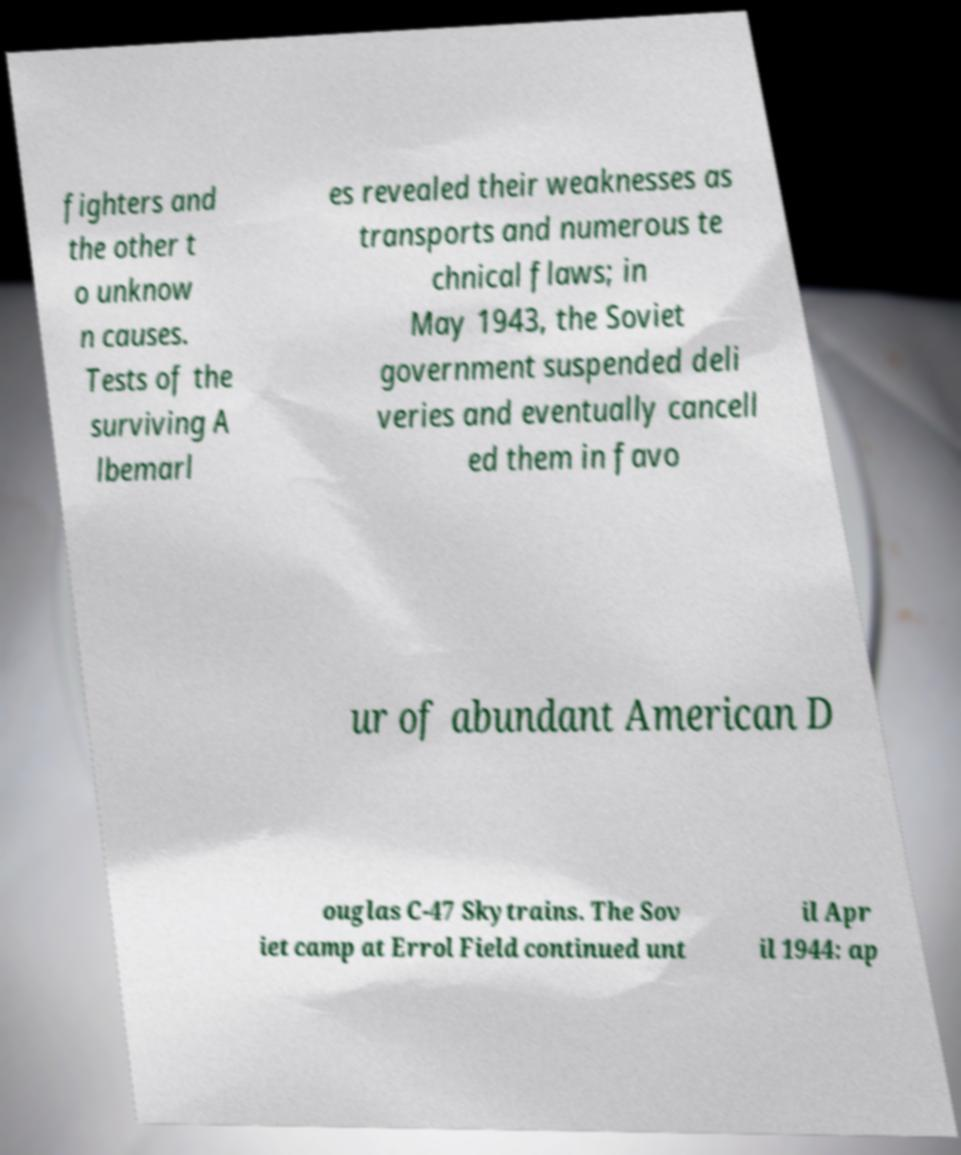Could you assist in decoding the text presented in this image and type it out clearly? fighters and the other t o unknow n causes. Tests of the surviving A lbemarl es revealed their weaknesses as transports and numerous te chnical flaws; in May 1943, the Soviet government suspended deli veries and eventually cancell ed them in favo ur of abundant American D ouglas C-47 Skytrains. The Sov iet camp at Errol Field continued unt il Apr il 1944: ap 